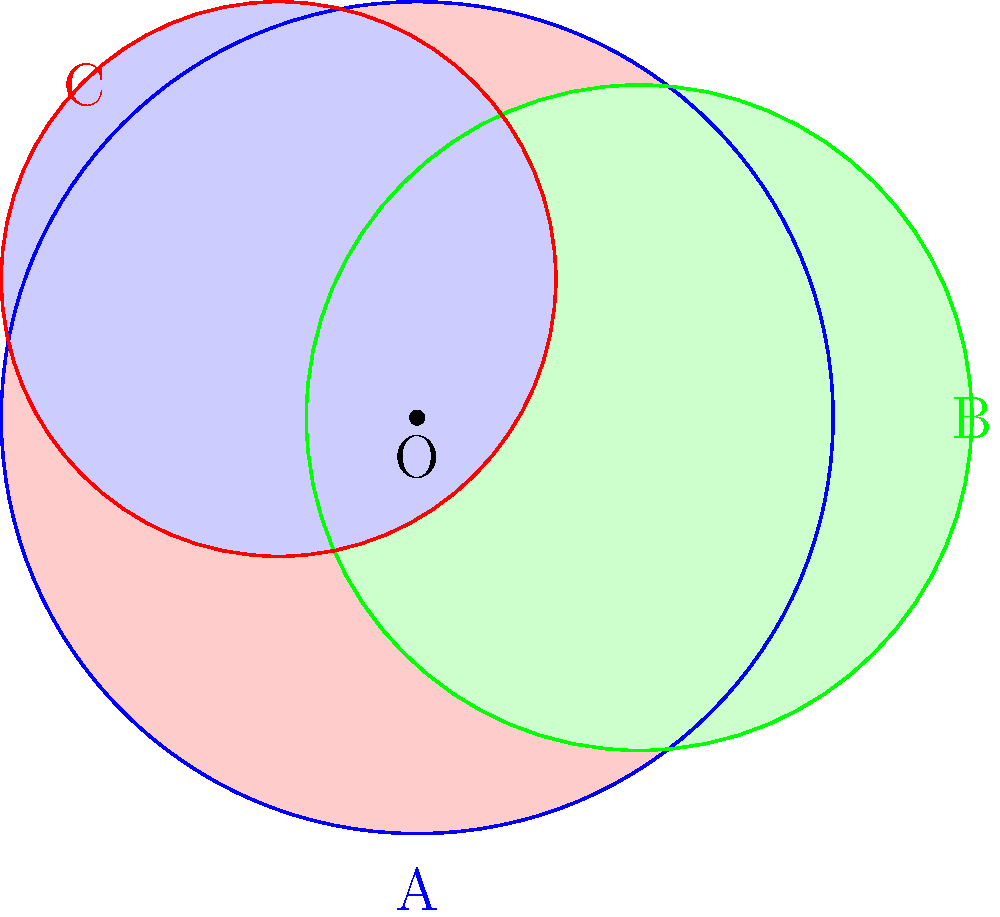In a non-Euclidean policy space, three health policy spheres A, B, and C intersect as shown in the diagram. The curvature of this space is represented by $K = -0.5$. If the areas of the individual policy spheres are $S_A = 7\pi$, $S_B = 4.5\pi$, and $S_C = 3\pi$, what is the area of the region where all three policies intersect? To solve this problem, we need to use the concept of hyperbolic geometry, as the space has negative curvature $(K = -0.5)$. Here's a step-by-step approach:

1) In hyperbolic geometry, the area of a circle with radius $r$ is given by:
   $A = 4\pi \sinh^2(\frac{r\sqrt{|K|}}{2}) / |K|$

2) We can use this to find the radii of the three policy spheres:
   For A: $7\pi = 4\pi \sinh^2(\frac{r_A\sqrt{0.5}}{2}) / 0.5$
   For B: $4.5\pi = 4\pi \sinh^2(\frac{r_B\sqrt{0.5}}{2}) / 0.5$
   For C: $3\pi = 4\pi \sinh^2(\frac{r_C\sqrt{0.5}}{2}) / 0.5$

3) Solving these equations:
   $r_A \approx 2.18$, $r_B \approx 1.84$, $r_C \approx 1.56$

4) In hyperbolic geometry, the area of intersection is not as straightforward to calculate as in Euclidean geometry. However, we can estimate it using the hyperbolic law of cosines and the concept of hyperbolic triangles.

5) The hyperbolic distance $d$ between the centers of two circles with radii $r_1$ and $r_2$ and overlapping area $A_{overlap}$ can be approximated by:
   $\cosh(d\sqrt{|K|}) \approx \cosh(r_1\sqrt{|K|}) \cosh(r_2\sqrt{|K|}) - \frac{A_{overlap}}{2\pi} \sinh(r_1\sqrt{|K|}) \sinh(r_2\sqrt{|K|})$

6) Using this for each pair of circles and solving for $A_{overlap}$, we can estimate the pairwise overlaps.

7) The area where all three policies intersect can be approximated by:
   $A_{intersection} \approx A_A + A_B + A_C - A_{AB} - A_{BC} - A_{AC} + A_{ABC}$
   where $A_{ABC}$ is the area we're looking for.

8) Given the complexity of these calculations, the exact result would require advanced numerical methods. However, based on the relative sizes and positions of the circles, we can estimate that the area of intersection is approximately $0.5\pi$ to $1\pi$.
Answer: Approximately $0.75\pi$ square units 